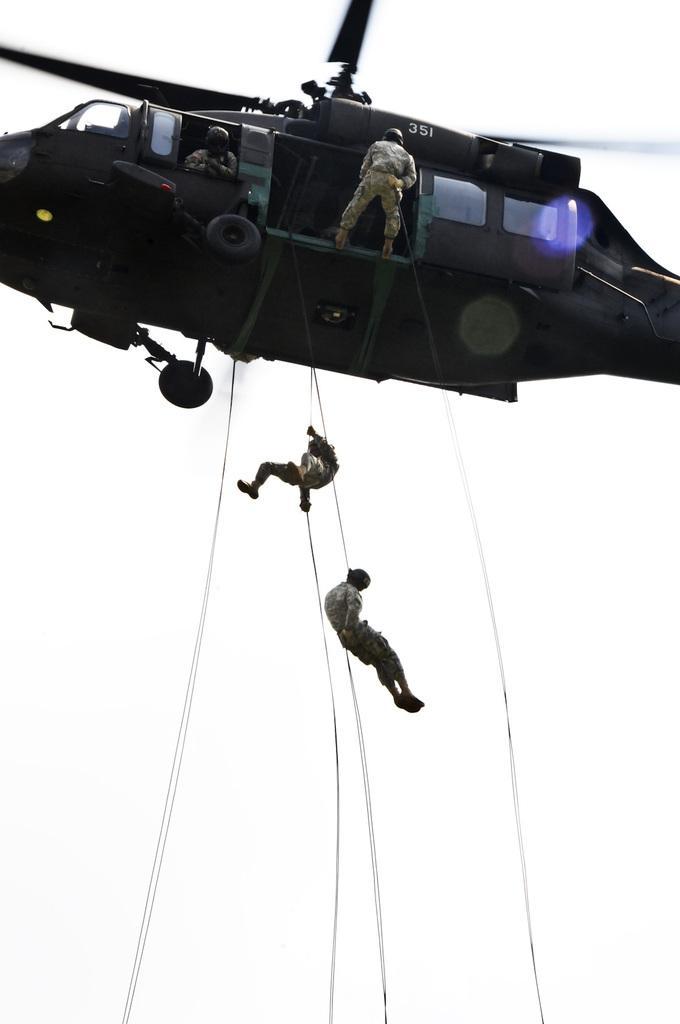Could you give a brief overview of what you see in this image? In this image, we can see persons wearing clothes. There is a helicopter at the top of the image. There are two persons in the middle of the image hanging on ropes. 